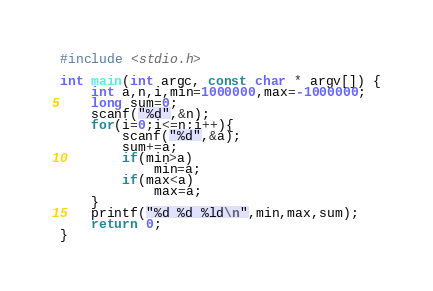Convert code to text. <code><loc_0><loc_0><loc_500><loc_500><_C_>#include <stdio.h>

int main(int argc, const char * argv[]) {
    int a,n,i,min=1000000,max=-1000000;
    long sum=0;
    scanf("%d",&n);
    for(i=0;i<=n;i++){
        scanf("%d",&a);
        sum+=a;
        if(min>a)
            min=a;
        if(max<a)
            max=a;
    }
    printf("%d %d %ld\n",min,max,sum);
    return 0;
}</code> 